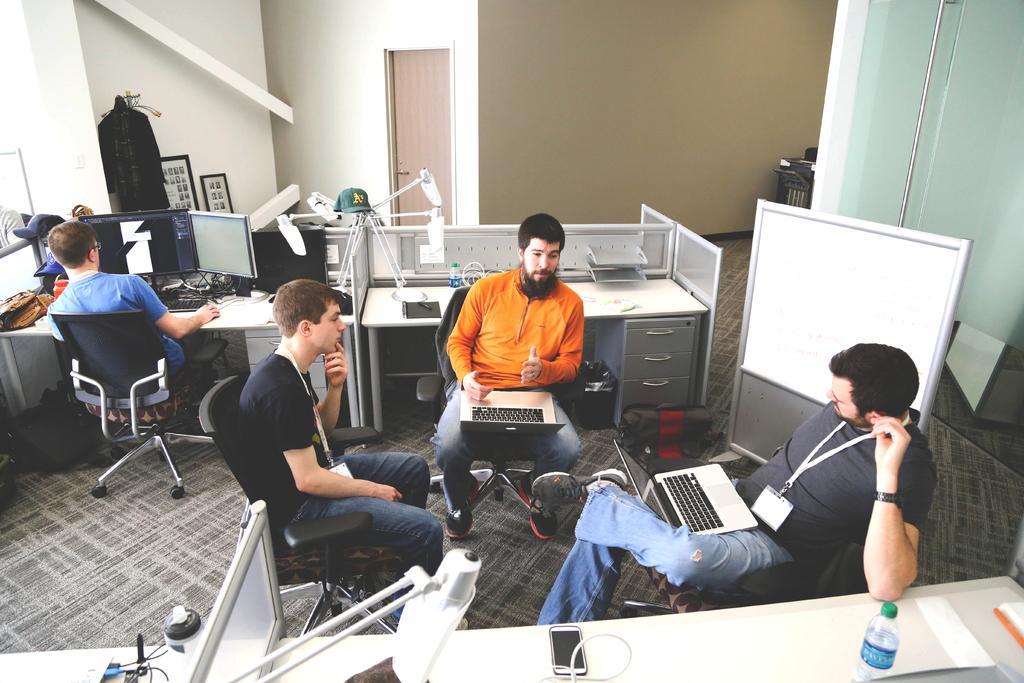Can you describe this image briefly? There are four people. They are sitting on a chair. There is a table. There is a laptop,bag,mobile,charger,computer system,keyboard and mouse on a table. We can see in the background there is a wall. 